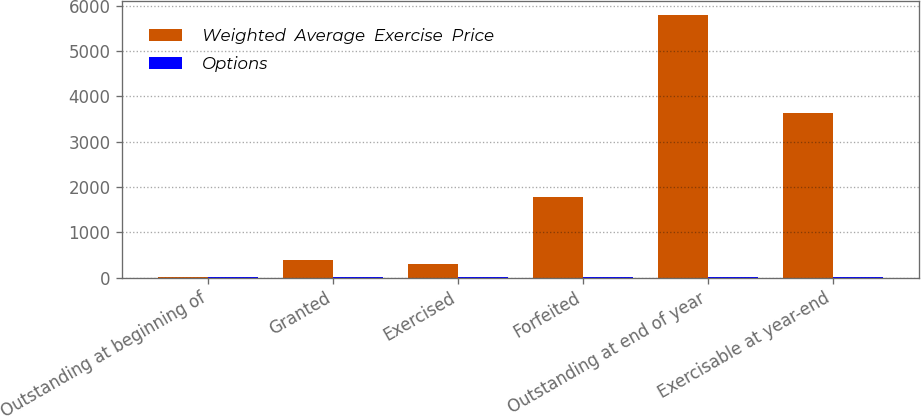<chart> <loc_0><loc_0><loc_500><loc_500><stacked_bar_chart><ecel><fcel>Outstanding at beginning of<fcel>Granted<fcel>Exercised<fcel>Forfeited<fcel>Outstanding at end of year<fcel>Exercisable at year-end<nl><fcel>Weighted  Average  Exercise  Price<fcel>20.7<fcel>397<fcel>306<fcel>1784<fcel>5802<fcel>3627<nl><fcel>Options<fcel>20.47<fcel>13.53<fcel>10.75<fcel>19.83<fcel>20.7<fcel>19.92<nl></chart> 